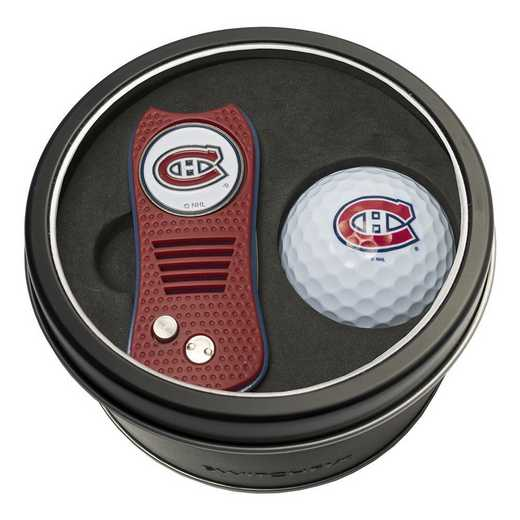Can you describe how these items might be used during a typical golf game? During a typical golf game, the golf ball would be used by players to play through the course, striking it with various clubs depending on the distance and strategic needs of each shot. The divot repair tool is used to repair the grass on the golf course after the golf ball has been struck; it fixes the marks left on the turf from the impact of the ball or the golf club. This not only helps maintain the course but also preserves the playing surface for future players. 